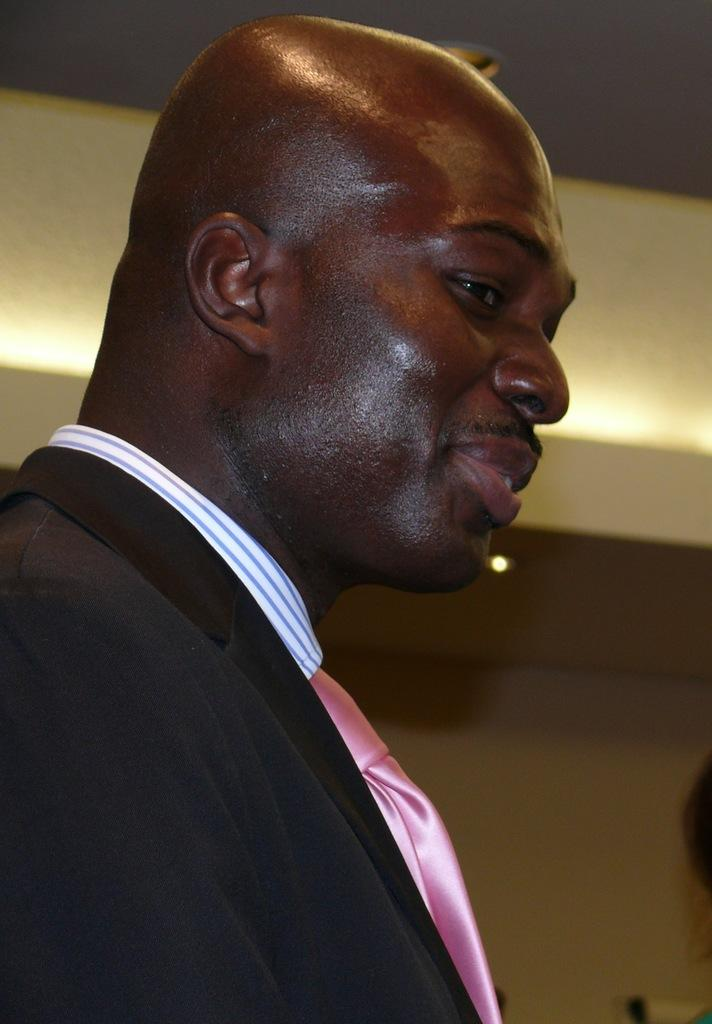Who is present in the image? There is a man in the image. What can be seen on the ceiling in the background of the image? There is light on the ceiling in the background of the image. What else can be seen in the background of the image? There are objects visible in the background of the image. What is the background of the image composed of? There is a wall in the background of the image. How many sisters does the man have in the image? There is no information about the man's sisters in the image. What type of rake is being used by the man in the image? There is no rake present in the image. 